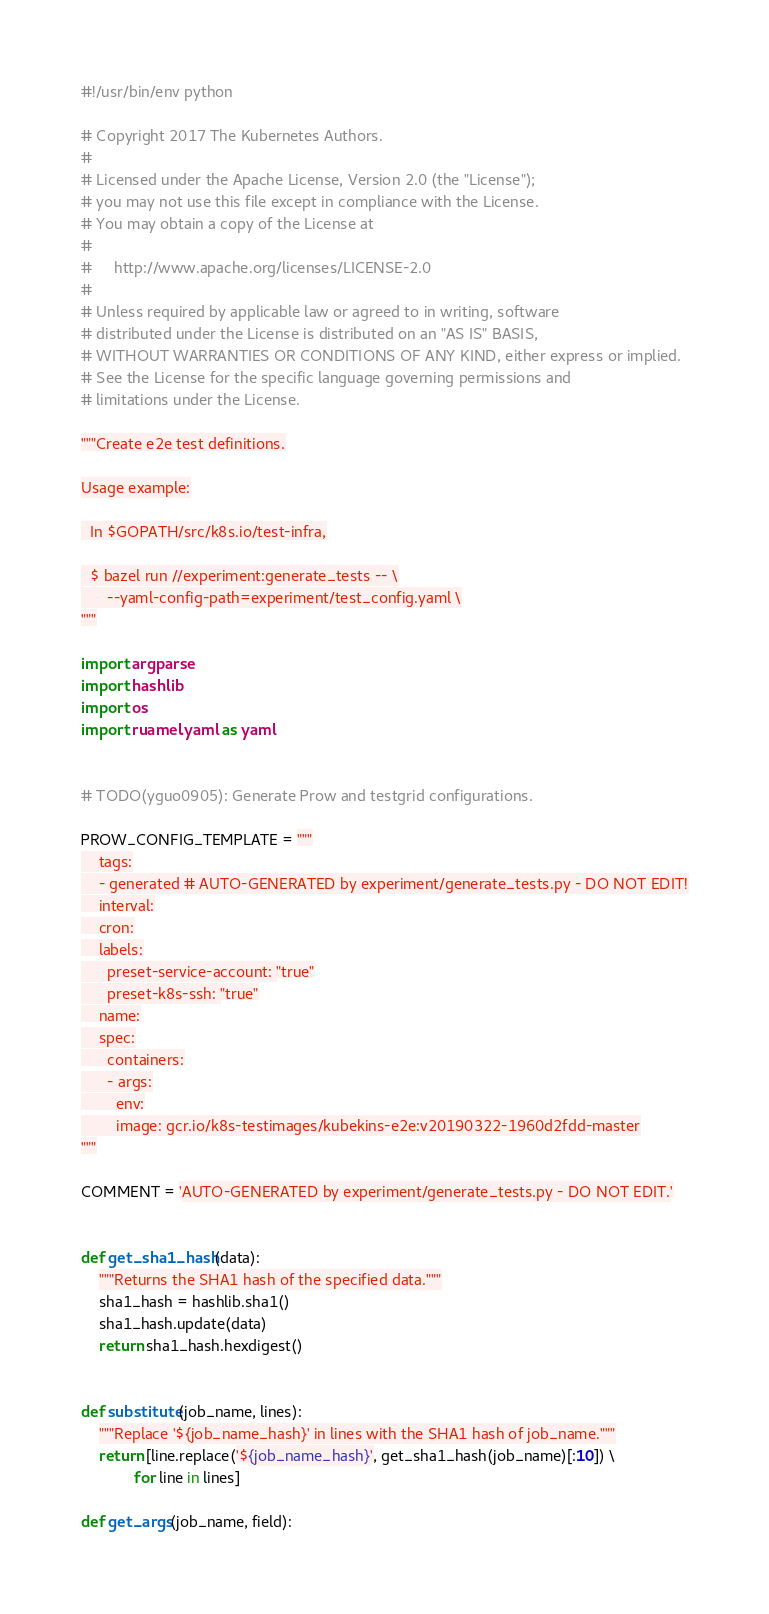Convert code to text. <code><loc_0><loc_0><loc_500><loc_500><_Python_>#!/usr/bin/env python

# Copyright 2017 The Kubernetes Authors.
#
# Licensed under the Apache License, Version 2.0 (the "License");
# you may not use this file except in compliance with the License.
# You may obtain a copy of the License at
#
#     http://www.apache.org/licenses/LICENSE-2.0
#
# Unless required by applicable law or agreed to in writing, software
# distributed under the License is distributed on an "AS IS" BASIS,
# WITHOUT WARRANTIES OR CONDITIONS OF ANY KIND, either express or implied.
# See the License for the specific language governing permissions and
# limitations under the License.

"""Create e2e test definitions.

Usage example:

  In $GOPATH/src/k8s.io/test-infra,

  $ bazel run //experiment:generate_tests -- \
      --yaml-config-path=experiment/test_config.yaml \
"""

import argparse
import hashlib
import os
import ruamel.yaml as yaml


# TODO(yguo0905): Generate Prow and testgrid configurations.

PROW_CONFIG_TEMPLATE = """
    tags:
    - generated # AUTO-GENERATED by experiment/generate_tests.py - DO NOT EDIT!
    interval:
    cron:
    labels:
      preset-service-account: "true"
      preset-k8s-ssh: "true"
    name:
    spec:
      containers:
      - args:
        env:
        image: gcr.io/k8s-testimages/kubekins-e2e:v20190322-1960d2fdd-master
"""

COMMENT = 'AUTO-GENERATED by experiment/generate_tests.py - DO NOT EDIT.'


def get_sha1_hash(data):
    """Returns the SHA1 hash of the specified data."""
    sha1_hash = hashlib.sha1()
    sha1_hash.update(data)
    return sha1_hash.hexdigest()


def substitute(job_name, lines):
    """Replace '${job_name_hash}' in lines with the SHA1 hash of job_name."""
    return [line.replace('${job_name_hash}', get_sha1_hash(job_name)[:10]) \
            for line in lines]

def get_args(job_name, field):</code> 